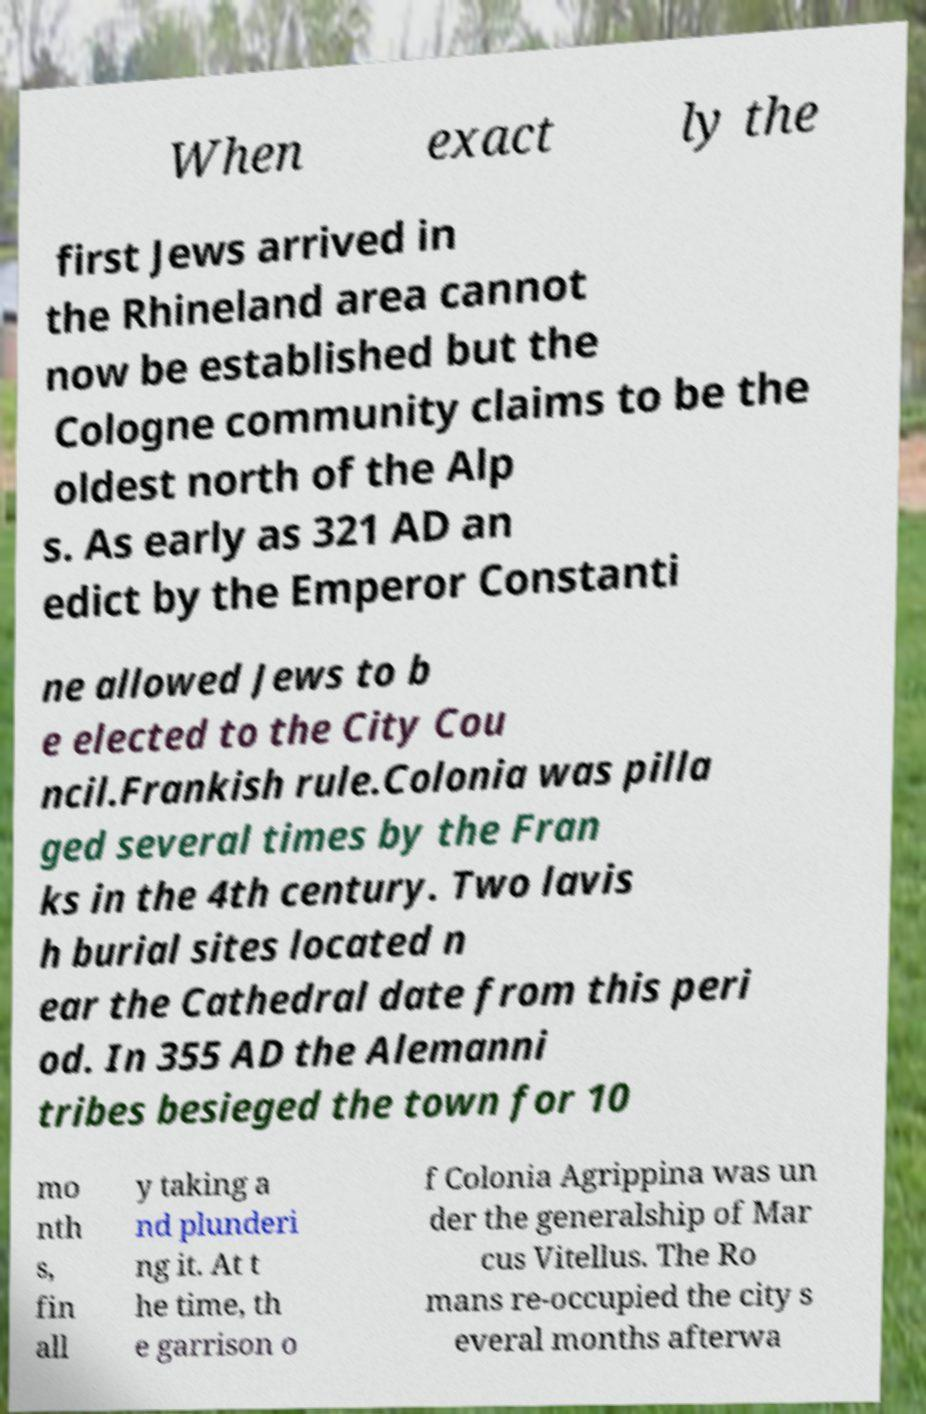What messages or text are displayed in this image? I need them in a readable, typed format. When exact ly the first Jews arrived in the Rhineland area cannot now be established but the Cologne community claims to be the oldest north of the Alp s. As early as 321 AD an edict by the Emperor Constanti ne allowed Jews to b e elected to the City Cou ncil.Frankish rule.Colonia was pilla ged several times by the Fran ks in the 4th century. Two lavis h burial sites located n ear the Cathedral date from this peri od. In 355 AD the Alemanni tribes besieged the town for 10 mo nth s, fin all y taking a nd plunderi ng it. At t he time, th e garrison o f Colonia Agrippina was un der the generalship of Mar cus Vitellus. The Ro mans re-occupied the city s everal months afterwa 